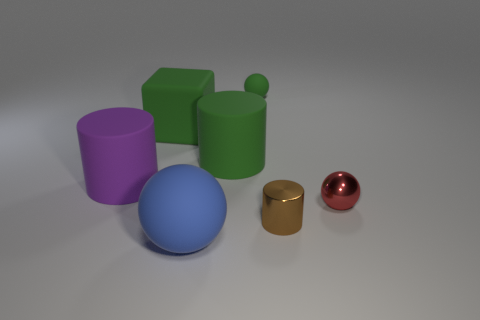Add 2 big purple rubber objects. How many objects exist? 9 Subtract all shiny balls. How many balls are left? 2 Subtract all blue spheres. How many spheres are left? 2 Subtract 1 cylinders. How many cylinders are left? 2 Subtract all cylinders. How many objects are left? 4 Subtract all blue cylinders. How many green spheres are left? 1 Subtract all matte cubes. Subtract all small green rubber balls. How many objects are left? 5 Add 4 red things. How many red things are left? 5 Add 1 big rubber balls. How many big rubber balls exist? 2 Subtract 0 blue blocks. How many objects are left? 7 